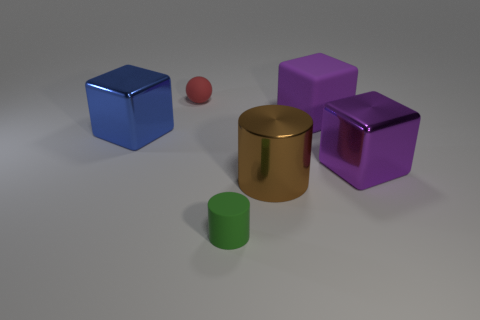What time of day does the lighting in the image suggest? The image seems to be artificially lit with neutral lighting, making it difficult to infer a time of day. It's a controlled environment, likely designed to highlight the geometry and colors of the objects without natural lighting effects. 